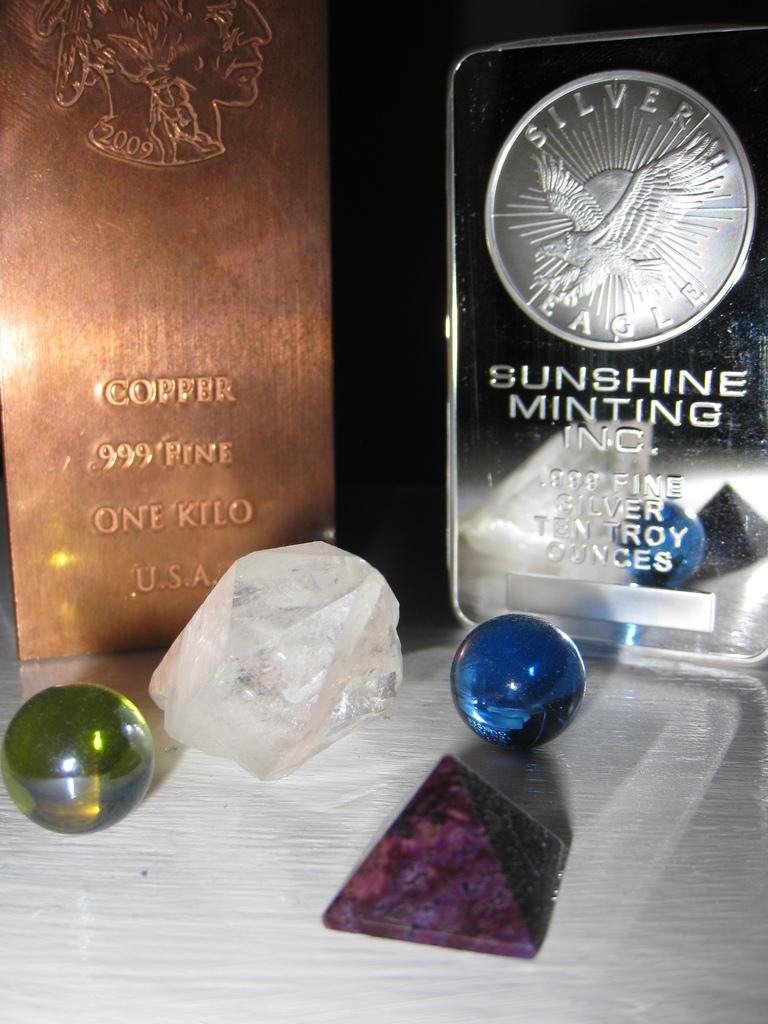<image>
Summarize the visual content of the image. Silver and copper box with one that says "999 Fine" on it. 